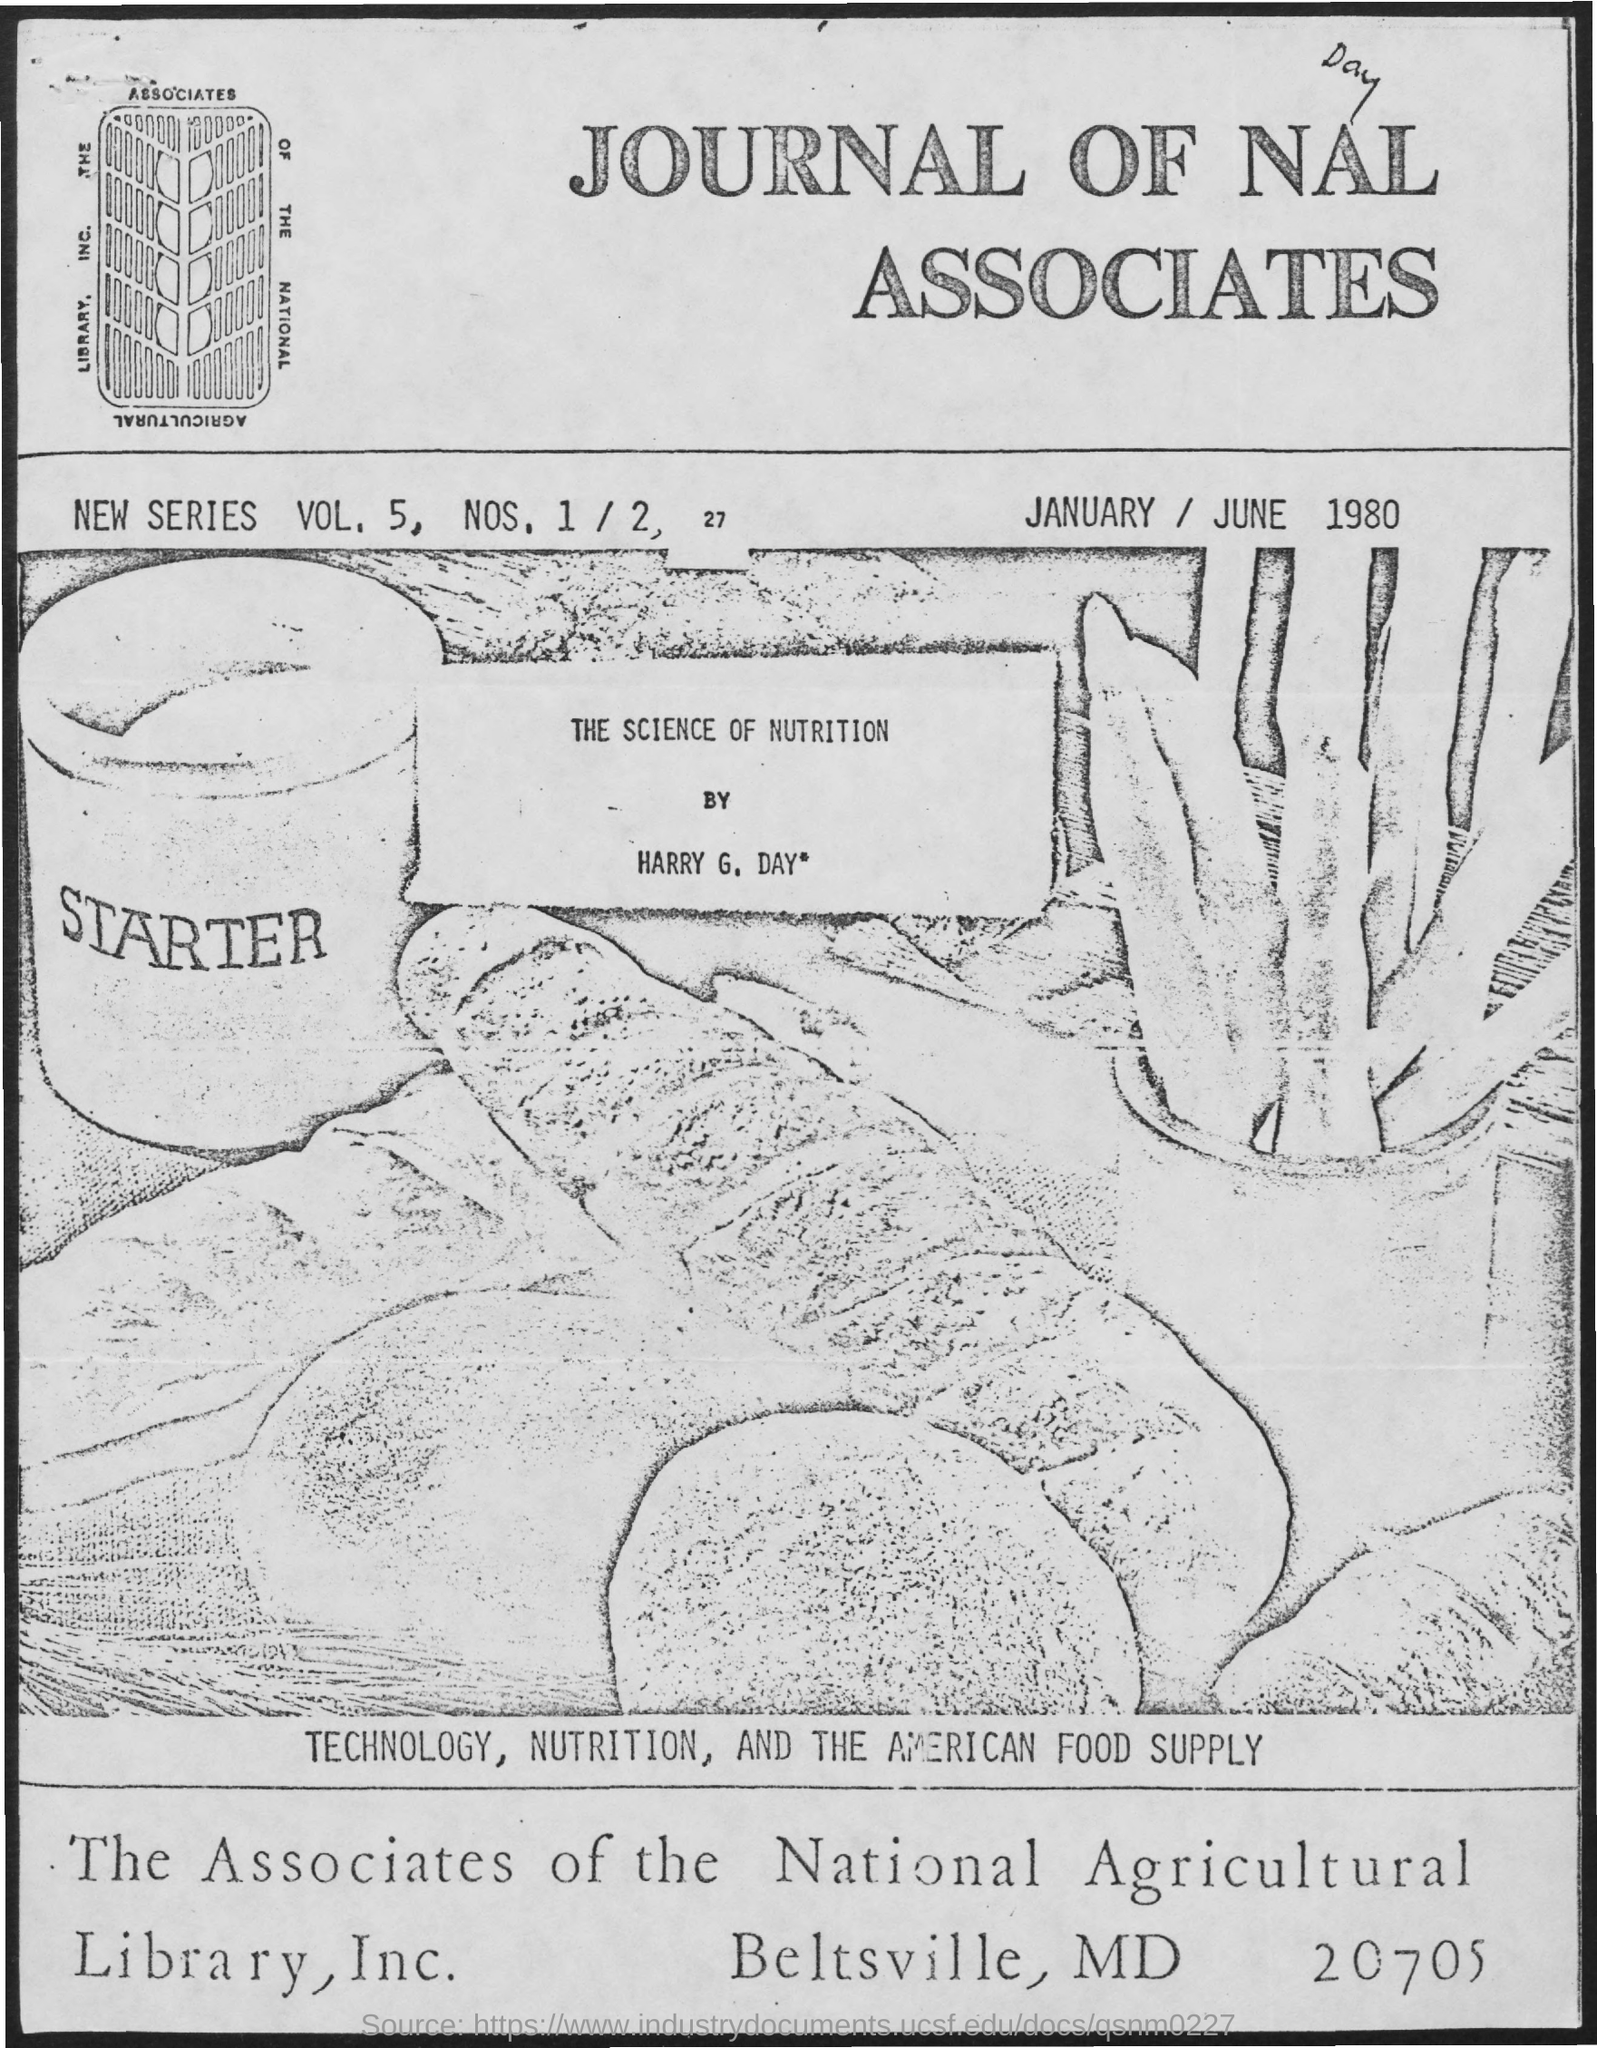Point out several critical features in this image. The volume number mentioned is 5. The name of the library mentioned is "The Associates of the National Agricultural Library, INc. 